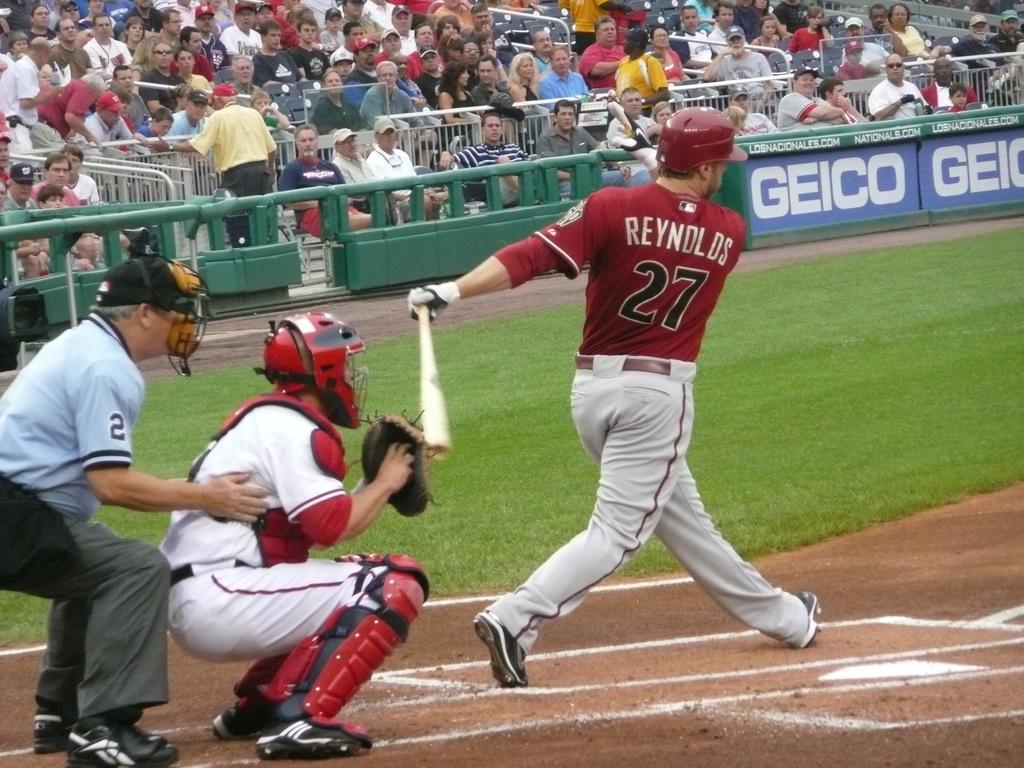What is the batters number?
Your answer should be very brief. 27. 